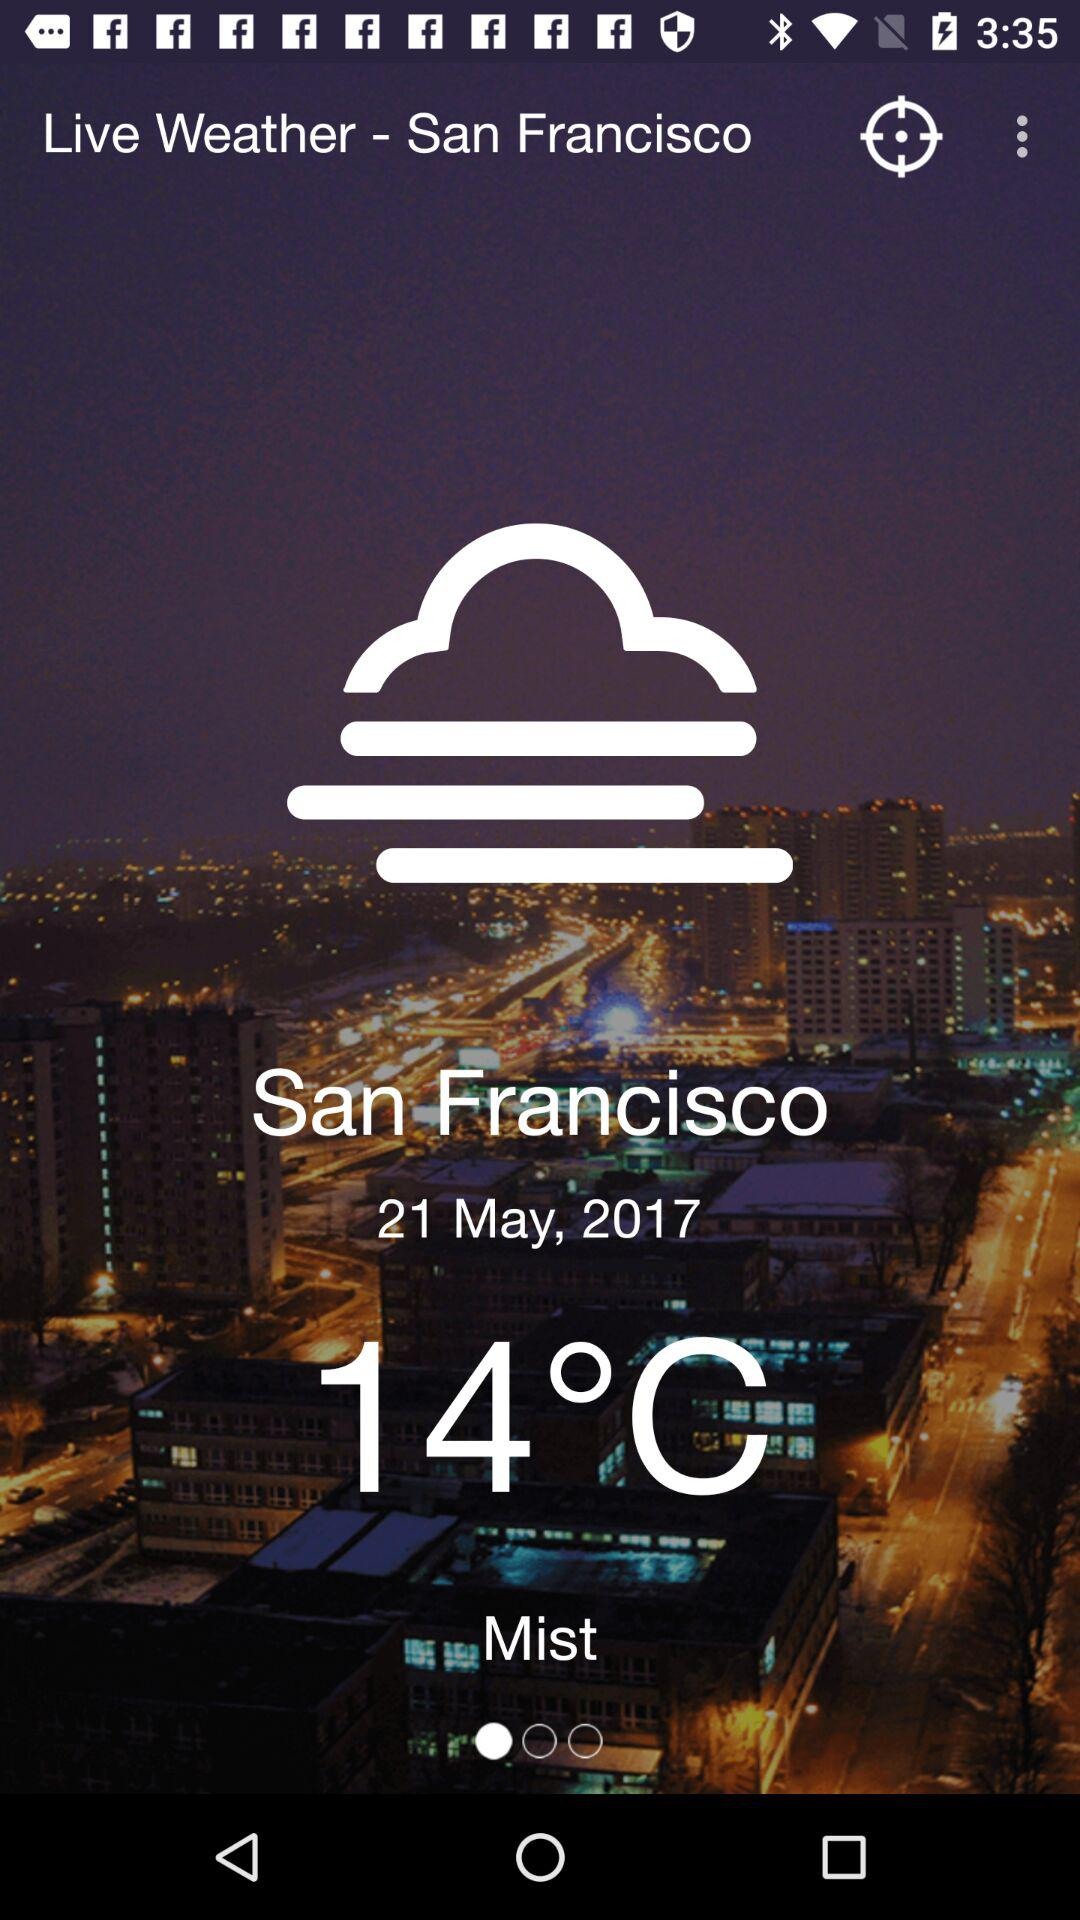What is the weather like in San Francisco? The weather is misty. 